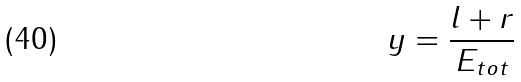<formula> <loc_0><loc_0><loc_500><loc_500>y = \frac { l + r } { E _ { t o t } }</formula> 